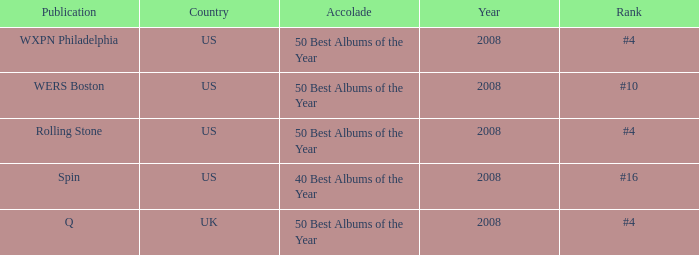In which year was the us's rank at #4? 2008, 2008. 